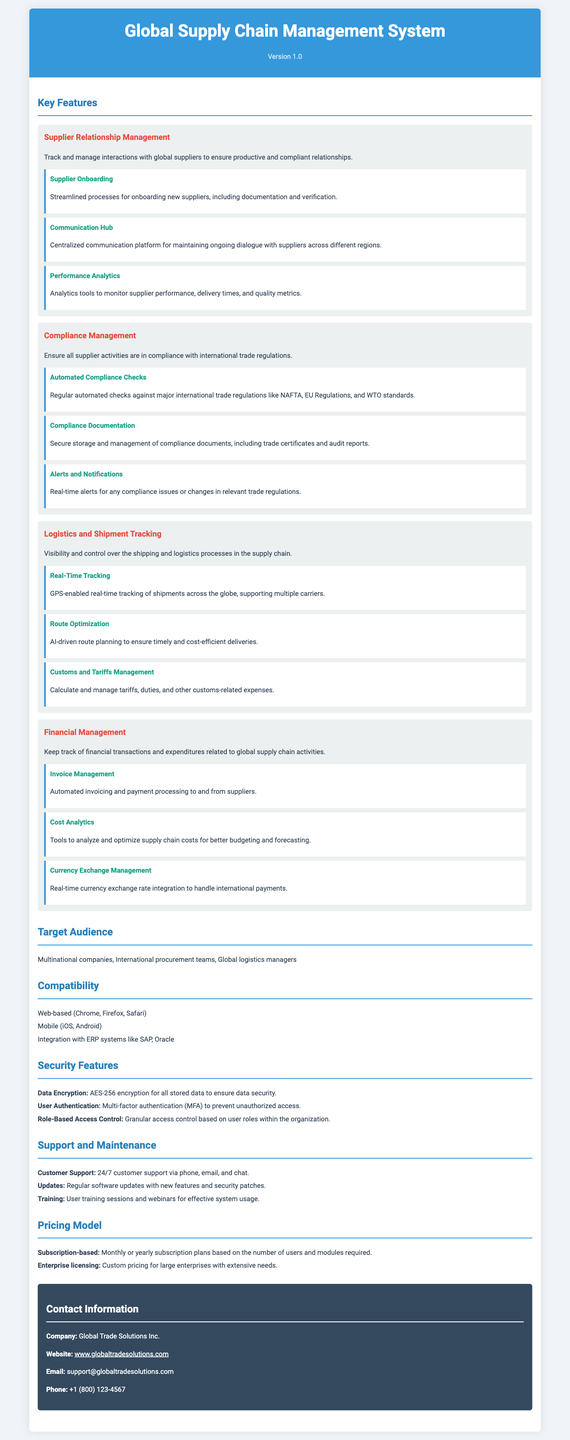what is the version of the system? The version of the system is mentioned in the header of the document.
Answer: Version 1.0 what feature relates to communication with suppliers? The document includes a section on Supplier Relationship Management, which highlights communication aspects.
Answer: Communication Hub how many key features are listed in the document? The document outlines a total of four key features in the specification sheet.
Answer: Four what kind of analytics tools are included in the system? The subfeature of Performance Analytics under Supplier Relationship Management specifies the type of analytics tools available.
Answer: Analytics tools what is the target audience for the system? The target audience section specifies the types of users intended for the system.
Answer: Multinational companies, International procurement teams, Global logistics managers how are compliance issues addressed in the system? The Compliance Management feature lists specific ways compliance issues are addressed within the system.
Answer: Real-time alerts what is the primary mode of access for this system? The Compatibility section indicates how users can access the system.
Answer: Web-based and Mobile what functionality helps optimize deliveries? The Logistics and Shipment Tracking feature includes specific tools for optimizing deliveries.
Answer: AI-driven route planning what type of support is offered with the system? The Support and Maintenance section outlines the available customer support options.
Answer: 24/7 customer support 